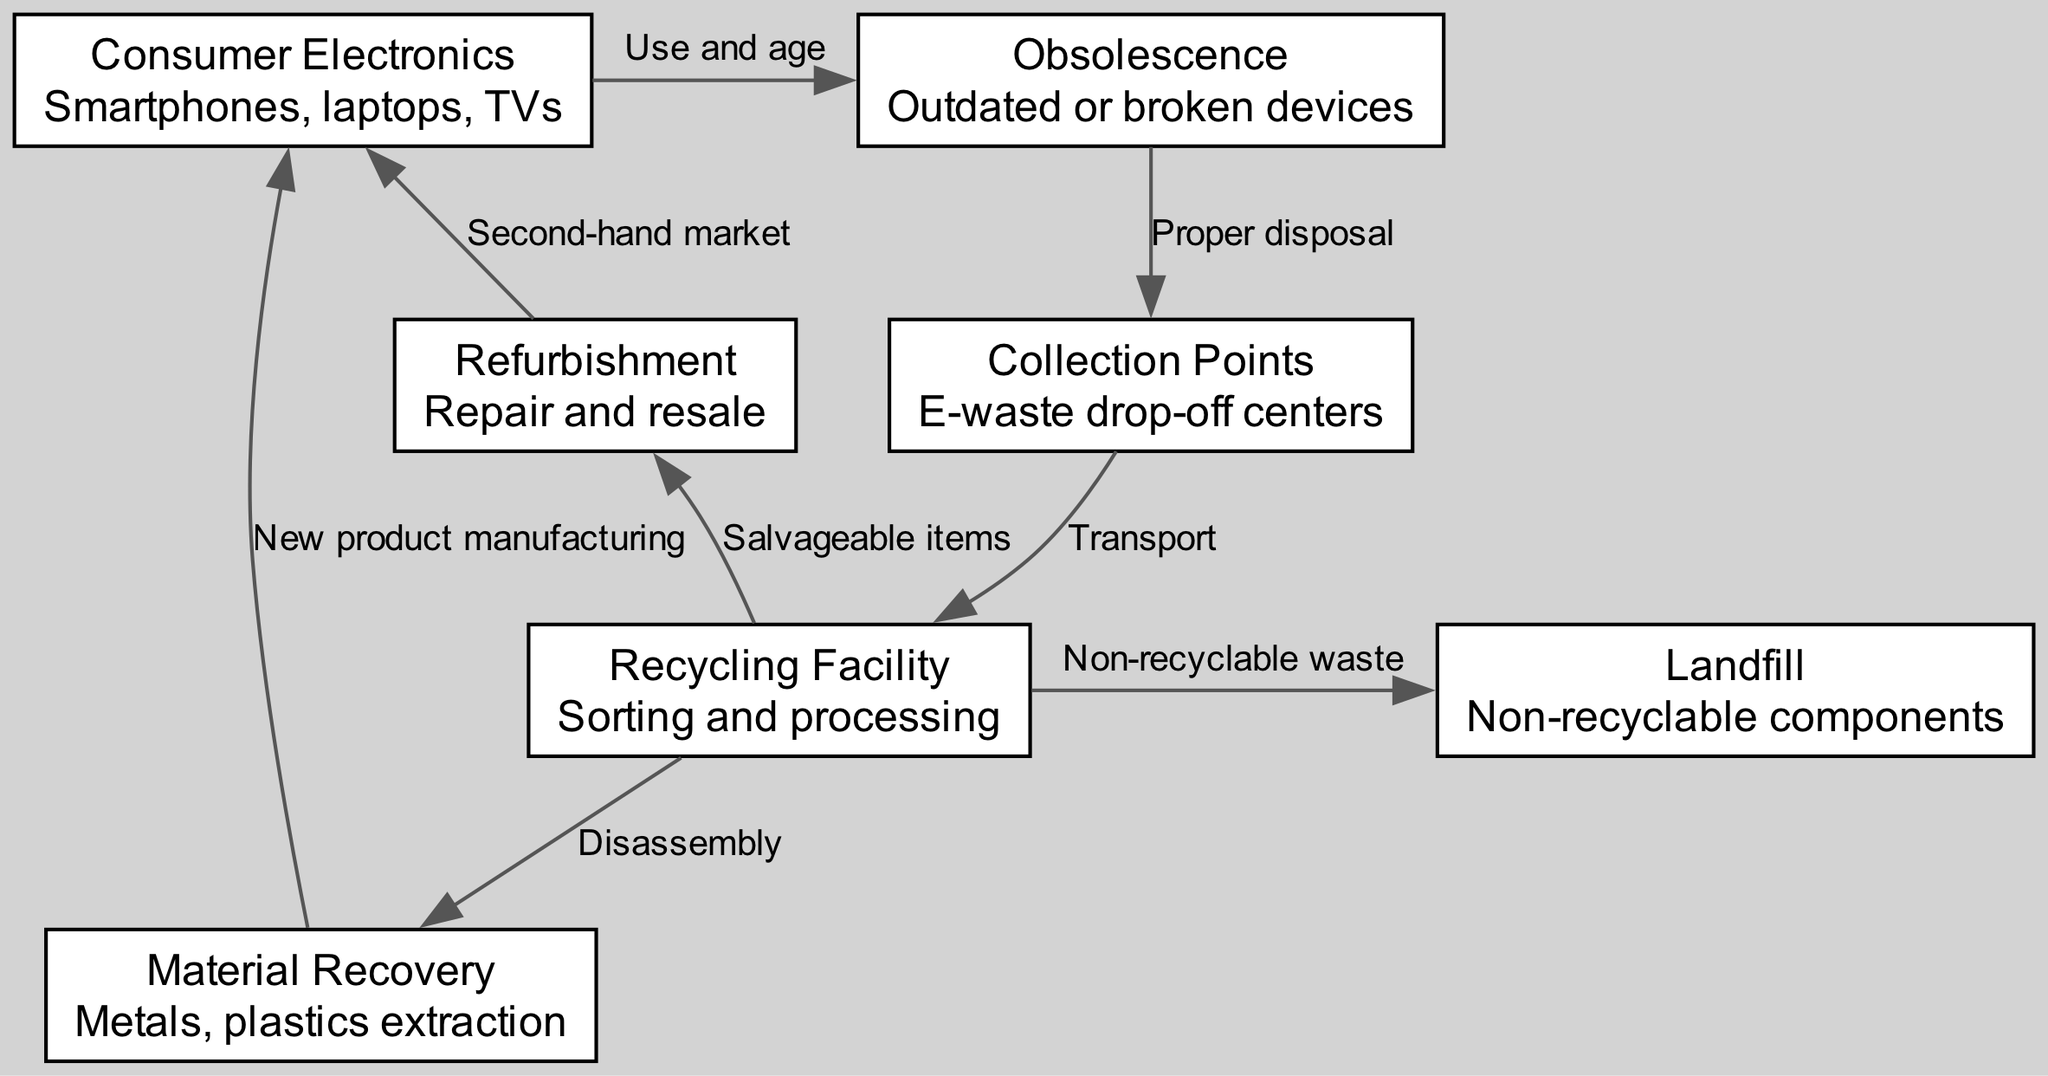What is the first node in the e-waste lifecycle? The first node listed in the diagram is "Consumer Electronics," which represents devices like smartphones, laptops, and TVs. Thus, "Consumer Electronics" is the first step in the lifecycle of e-waste.
Answer: Consumer Electronics How many nodes are present in the diagram? By counting all the distinct nodes represented in the diagram, there are a total of seven nodes: Consumer Electronics, Obsolescence, Collection Points, Recycling Facility, Material Recovery, Refurbishment, and Landfill.
Answer: Seven What is the relationship labeled between Obsolescence and Collection Points? The relationship labeled in the diagram between the node "Obsolescence" and the node "Collection Points" is defined as "Proper disposal." This indicates that the action taken for obsolete devices is to dispose of them correctly at collection points.
Answer: Proper disposal From which node do salvageable items come? Salvageable items are derived from the "Recycling Facility." According to the diagram, after sorting and processing, the recycling facility identifies which items can be salvaged for reuse or refurbishment.
Answer: Recycling Facility Where do non-recyclable components end up? Non-recyclable components end up in the "Landfill." The diagram indicates that the recycling facility sends any materials that cannot be recycled to the landfill for disposal.
Answer: Landfill What method is shown for dealing with outdated devices? The method shown for dealing with outdated devices is "Proper disposal." This is represented by the process of taking obsolete or broken devices to collection points for responsible disposal.
Answer: Proper disposal Which products are indicated to result from Material Recovery? The products indicated to result from Material Recovery are "New product manufacturing." This implies that extracted materials such as metals and plastics from e-waste are reused to create new products.
Answer: New product manufacturing What does the edge from Refurbishment lead to? The edge from "Refurbishment" leads to "Consumer Electronics," indicating that refurbished items are reintroduced into the market as second-hand electronic devices.
Answer: Consumer Electronics How do salvageable items from the Recycling Facility impact consumer electronics? Salvageable items from the Recycling Facility enter the market through refurbishment, allowing them to be sold again as second-hand consumer electronics. This illustrates a sustainable pathway for used devices.
Answer: Second-hand market 